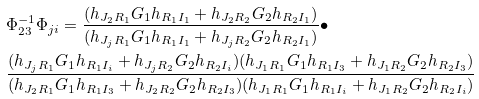Convert formula to latex. <formula><loc_0><loc_0><loc_500><loc_500>& { \Phi } _ { 2 3 } ^ { - 1 } { \Phi } _ { j i } = \frac { ( h _ { J _ { 2 } R _ { 1 } } G _ { 1 } h _ { R _ { 1 } I _ { 1 } } + h _ { J _ { 2 } R _ { 2 } } G _ { 2 } h _ { R _ { 2 } I _ { 1 } } ) } { ( h _ { J _ { j } R _ { 1 } } G _ { 1 } h _ { R _ { 1 } I _ { 1 } } + h _ { J _ { j } R _ { 2 } } G _ { 2 } h _ { R _ { 2 } I _ { 1 } } ) } \bullet \\ & \frac { ( h _ { J _ { j } R _ { 1 } } G _ { 1 } h _ { R _ { 1 } I _ { i } } + h _ { J _ { j } R _ { 2 } } G _ { 2 } h _ { R _ { 2 } I _ { i } } ) ( h _ { J _ { 1 } R _ { 1 } } G _ { 1 } h _ { R _ { 1 } I _ { 3 } } + h _ { J _ { 1 } R _ { 2 } } G _ { 2 } h _ { R _ { 2 } I _ { 3 } } ) } { ( h _ { J _ { 2 } R _ { 1 } } G _ { 1 } h _ { R _ { 1 } I _ { 3 } } + h _ { J _ { 2 } R _ { 2 } } G _ { 2 } h _ { R _ { 2 } I _ { 3 } } ) ( h _ { J _ { 1 } R _ { 1 } } G _ { 1 } h _ { R _ { 1 } I _ { i } } + h _ { J _ { 1 } R _ { 2 } } G _ { 2 } h _ { R _ { 2 } I _ { i } } ) } \\</formula> 